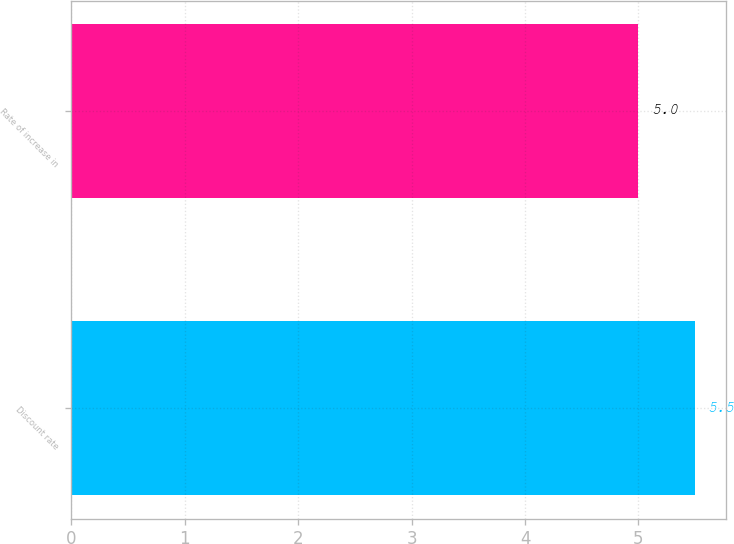Convert chart to OTSL. <chart><loc_0><loc_0><loc_500><loc_500><bar_chart><fcel>Discount rate<fcel>Rate of increase in<nl><fcel>5.5<fcel>5<nl></chart> 